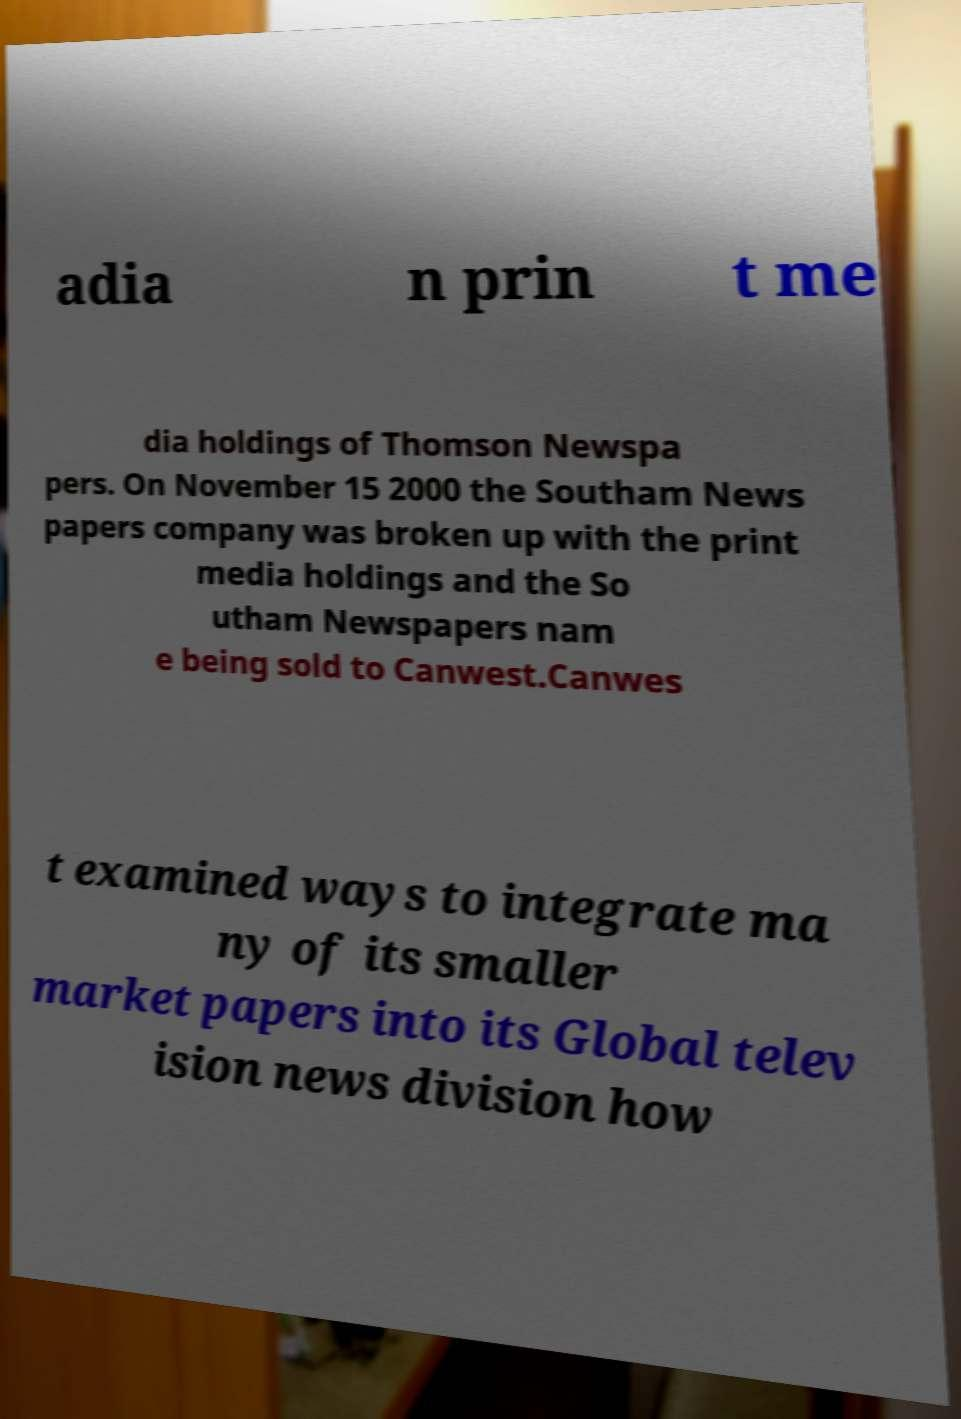Can you read and provide the text displayed in the image?This photo seems to have some interesting text. Can you extract and type it out for me? adia n prin t me dia holdings of Thomson Newspa pers. On November 15 2000 the Southam News papers company was broken up with the print media holdings and the So utham Newspapers nam e being sold to Canwest.Canwes t examined ways to integrate ma ny of its smaller market papers into its Global telev ision news division how 